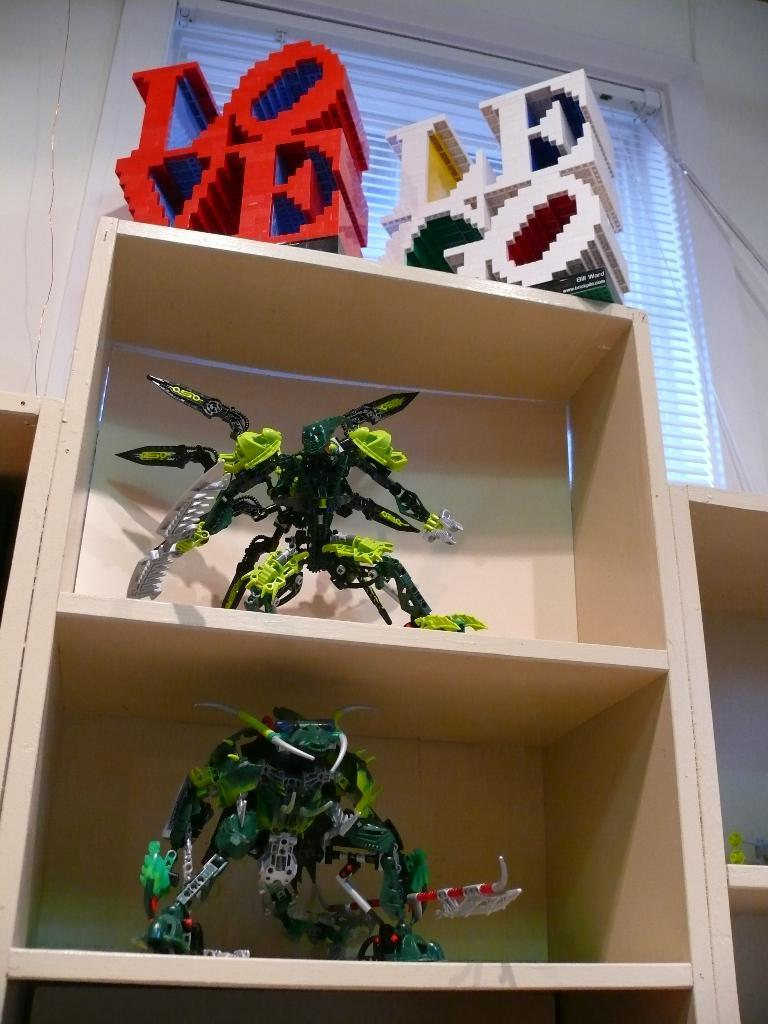What is located in the foreground of the picture? There is a wooden rack in the foreground of the picture. What is stored on the wooden rack? The wooden rack contains toys. What material are the toys made of? The toys are made of lego. What can be seen in the background of the picture? There is a window in the background of the picture. What color is the wall at the top of the image? The wall at the top of the image is painted white. How many suits can be seen hanging on the wall in the image? There are no suits visible in the image; the toys are made of lego and the wall is painted white. Can you see any snails crawling on the wooden rack in the image? There are no snails present in the image; the wooden rack contains lego toys. 